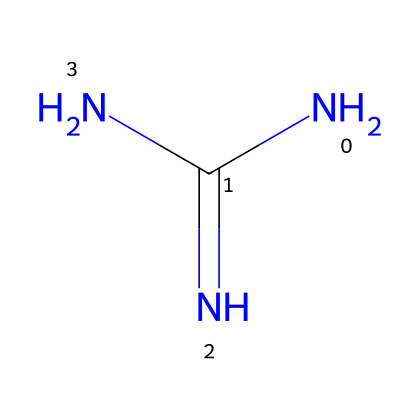What is the molecular formula of guanidine? The SMILES representation NC(=N)N indicates the number and types of atoms present. There are one carbon (C), four hydrogens (H), and three nitrogens (N), which together make the molecular formula C1H4N4.
Answer: C1H4N4 How many nitrogen atoms are in the structure? By examining the SMILES representation, we can identify that there are three nitrogen atoms (N) present in the chemical structure.
Answer: 3 Is guanidine a superbase? Guanidine is known for its strong basic properties and is classified as a superbase due to its ability to deprotonate weak acids.
Answer: Yes What functional groups are present in guanidine? The structure reveals that guanidine contains amino groups (–NH2) and a guanidine functional group, characterized by the arrangement of nitrogen and carbon.
Answer: Amino group What is the significance of nitrogen's presence in guanidine's reactivity? The presence of multiple nitrogen atoms contributes to guanidine's strong basicity and high reactivity, making it an effective superbase due to the availability of lone pairs on the nitrogen atoms for protonation reactions.
Answer: High reactivity What does the resonance structure of the functional groups in guanidine imply? The resonance structure indicates that the lone pairs of the nitrogen can delocalize, contributing to the stability and increased basicity of guanidine, which is critical in its effectiveness as a superbase.
Answer: Increased basicity 